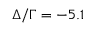Convert formula to latex. <formula><loc_0><loc_0><loc_500><loc_500>\Delta / \Gamma = - 5 . 1</formula> 